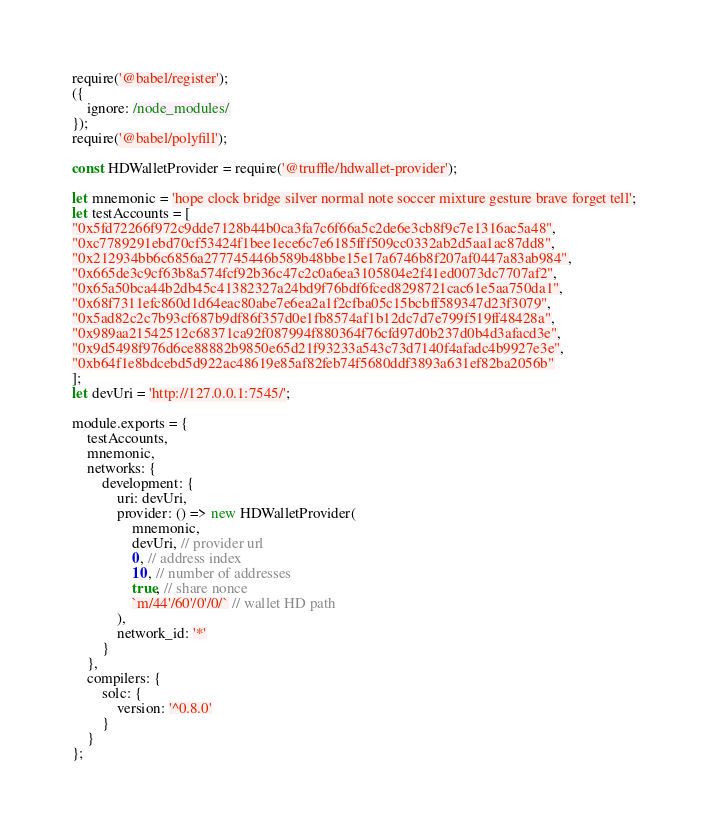Convert code to text. <code><loc_0><loc_0><loc_500><loc_500><_JavaScript_>require('@babel/register');
({
    ignore: /node_modules/
});
require('@babel/polyfill');

const HDWalletProvider = require('@truffle/hdwallet-provider');

let mnemonic = 'hope clock bridge silver normal note soccer mixture gesture brave forget tell'; 
let testAccounts = [
"0x5fd72266f972c9dde7128b44b0ca3fa7c6f66a5c2de6e3cb8f9c7e1316ac5a48",
"0xc7789291ebd70cf53424f1bee1ece6c7e6185fff509cc0332ab2d5aa1ac87dd8",
"0x212934bb6c6856a277745446b589b48bbe15e17a6746b8f207af0447a83ab984",
"0x665de3c9cf63b8a574fcf92b36c47c2c0a6ea3105804e2f41ed0073dc7707af2",
"0x65a50bca44b2db45c41382327a24bd9f76bdf6fced8298721cac61e5aa750da1",
"0x68f7311efc860d1d64eac80abe7e6ea2a1f2cfba05c15bcbff589347d23f3079",
"0x5ad82c2c7b93cf687b9df86f357d0e1fb8574af1b12dc7d7e799f519ff48428a",
"0x989aa21542512c68371ca92f087994f880364f76cfd97d0b237d0b4d3afacd3e",
"0x9d5498f976d6ce88882b9850e65d21f93233a543c73d7140f4afadc4b9927e3e",
"0xb64f1e8bdcebd5d922ac48619e85af82feb74f5680ddf3893a631ef82ba2056b"
]; 
let devUri = 'http://127.0.0.1:7545/';

module.exports = {
    testAccounts,
    mnemonic,
    networks: {
        development: {
            uri: devUri,
            provider: () => new HDWalletProvider(
                mnemonic,
                devUri, // provider url
                0, // address index
                10, // number of addresses
                true, // share nonce
                `m/44'/60'/0'/0/` // wallet HD path
            ),
            network_id: '*'
        }
    },
    compilers: {
        solc: {
            version: '^0.8.0'
        }
    }
};

</code> 